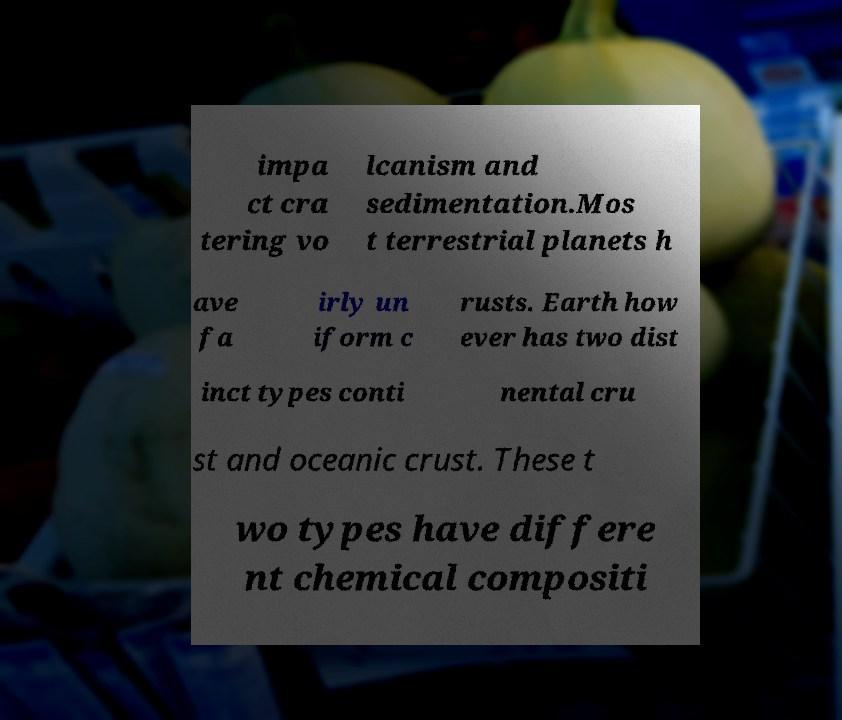There's text embedded in this image that I need extracted. Can you transcribe it verbatim? impa ct cra tering vo lcanism and sedimentation.Mos t terrestrial planets h ave fa irly un iform c rusts. Earth how ever has two dist inct types conti nental cru st and oceanic crust. These t wo types have differe nt chemical compositi 